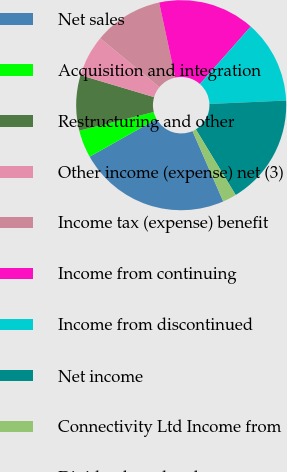<chart> <loc_0><loc_0><loc_500><loc_500><pie_chart><fcel>Net sales<fcel>Acquisition and integration<fcel>Restructuring and other<fcel>Other income (expense) net (3)<fcel>Income tax (expense) benefit<fcel>Income from continuing<fcel>Income from discontinued<fcel>Net income<fcel>Connectivity Ltd Income from<fcel>Dividends and cash<nl><fcel>23.4%<fcel>4.26%<fcel>8.51%<fcel>6.38%<fcel>10.64%<fcel>14.89%<fcel>12.77%<fcel>17.02%<fcel>2.13%<fcel>0.0%<nl></chart> 